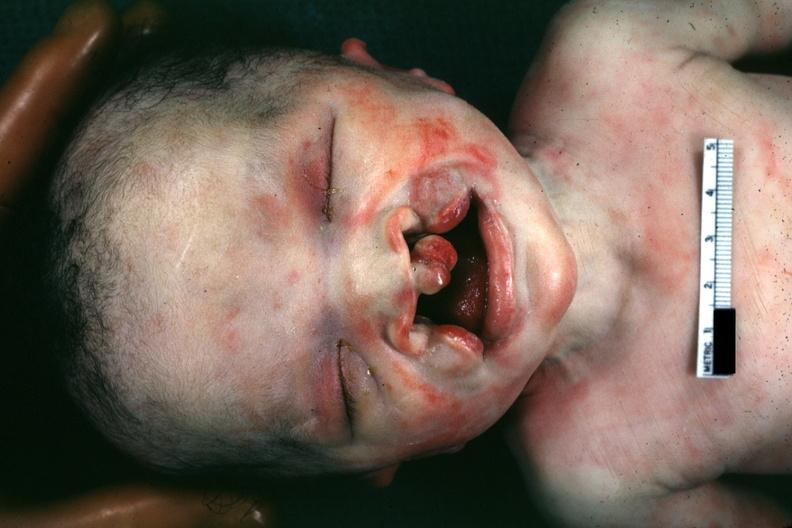s bilateral cleft palate present?
Answer the question using a single word or phrase. Yes 